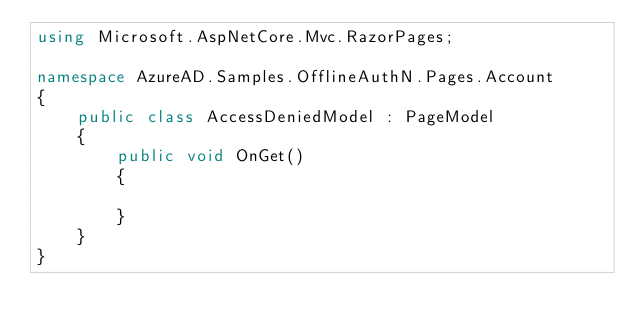<code> <loc_0><loc_0><loc_500><loc_500><_C#_>using Microsoft.AspNetCore.Mvc.RazorPages;

namespace AzureAD.Samples.OfflineAuthN.Pages.Account
{
    public class AccessDeniedModel : PageModel
    {
        public void OnGet()
        {

        }
    }
}
</code> 